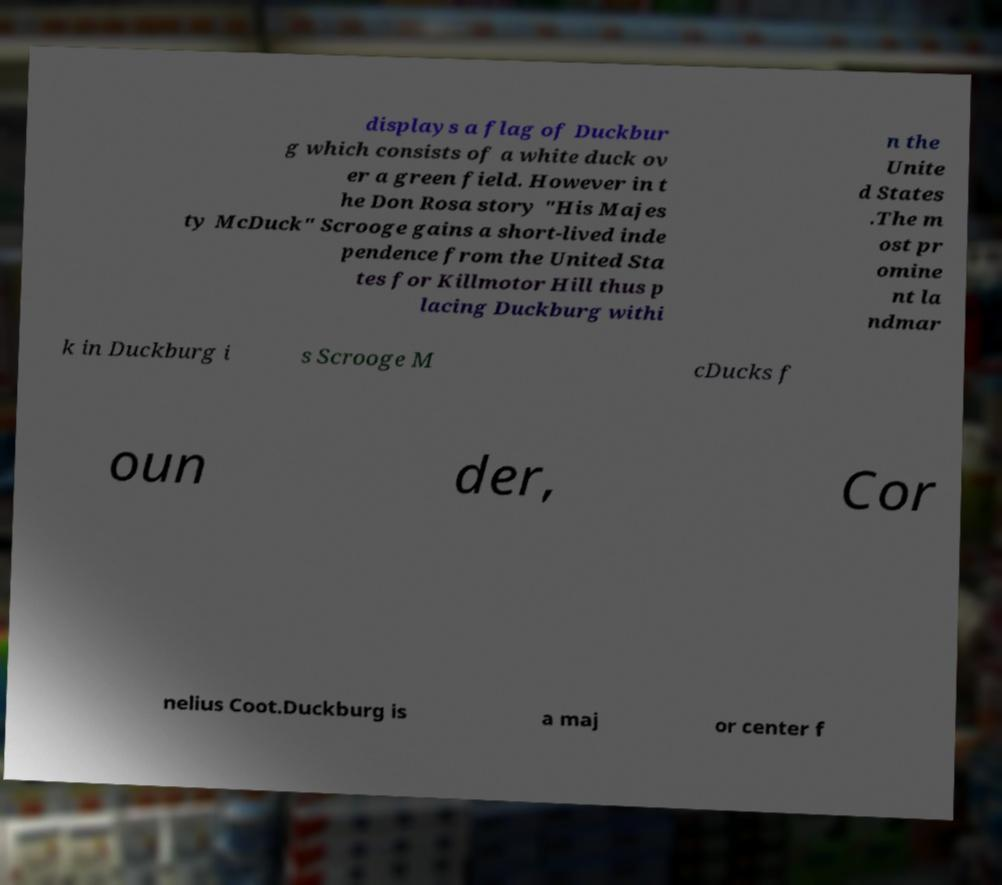Please read and relay the text visible in this image. What does it say? displays a flag of Duckbur g which consists of a white duck ov er a green field. However in t he Don Rosa story "His Majes ty McDuck" Scrooge gains a short-lived inde pendence from the United Sta tes for Killmotor Hill thus p lacing Duckburg withi n the Unite d States .The m ost pr omine nt la ndmar k in Duckburg i s Scrooge M cDucks f oun der, Cor nelius Coot.Duckburg is a maj or center f 